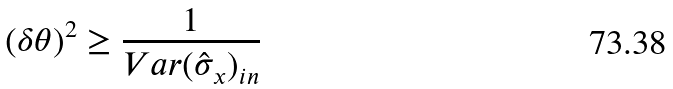Convert formula to latex. <formula><loc_0><loc_0><loc_500><loc_500>( \delta \theta ) ^ { 2 } \geq \frac { 1 } { V a r ( \hat { \sigma } _ { x } ) _ { i n } }</formula> 